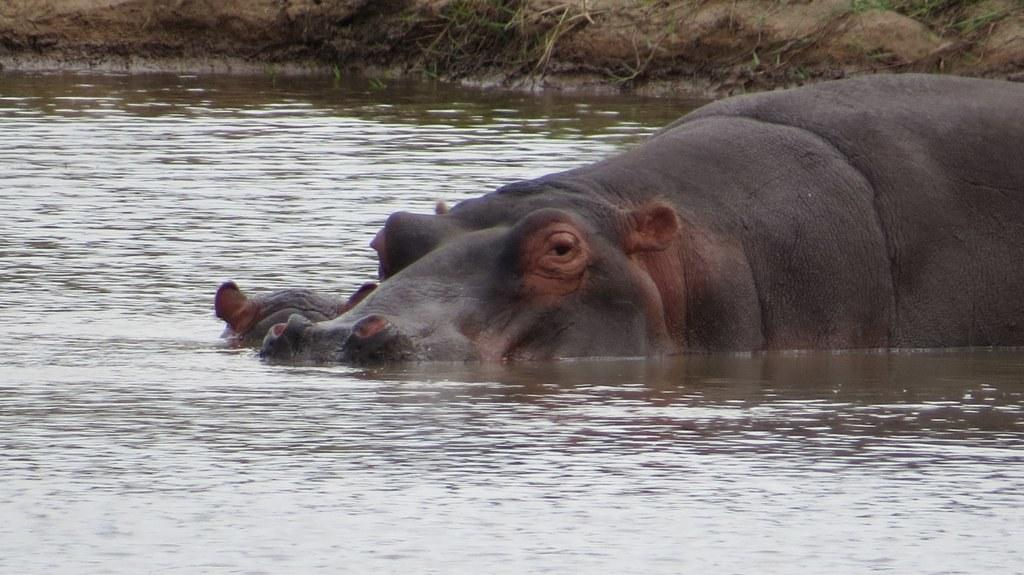What animal is the main subject of the image? There is a hippopotamus in the center of the image. Where is the hippopotamus located? The hippopotamus is in the water. What can be seen in the background of the image? There is ground visible in the background of the image. How many cats are sitting on the hippopotamus's head in the image? There are no cats present in the image, and therefore none are sitting on the hippopotamus's head. 